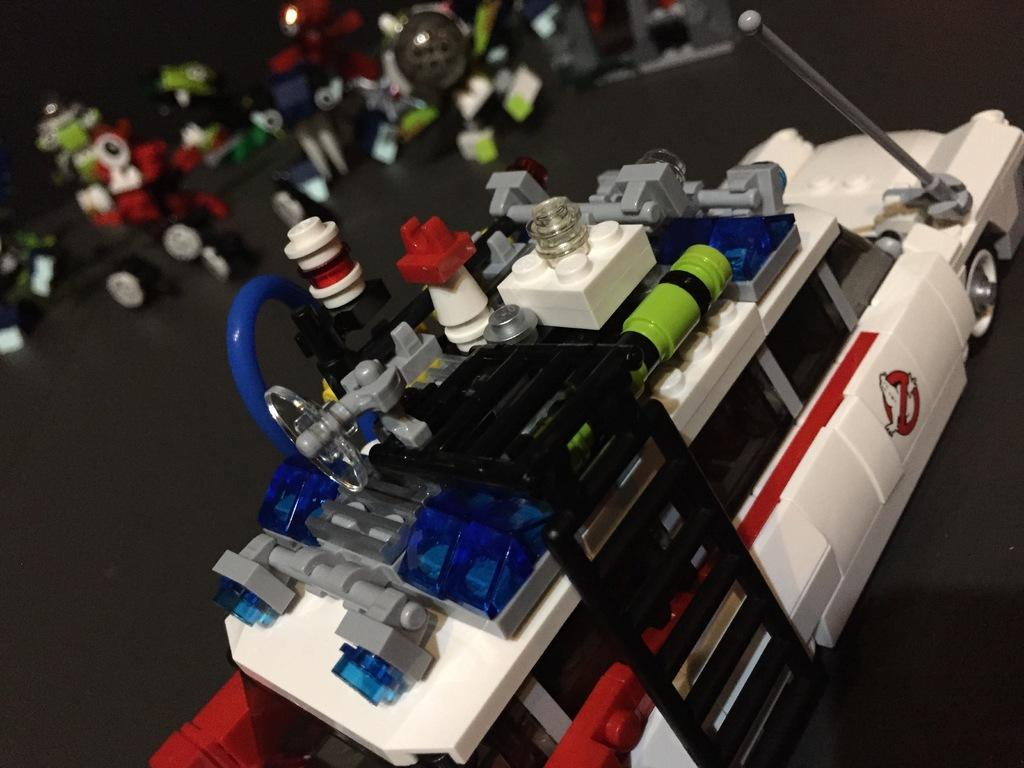What is the main subject of the image? The main subject of the image is toys. Can you describe the toy car in the image? There is a toy car in white color in the front of the image. Are there any toys visible in the background of the image? Yes, there are toys in the background of the image. What type of drink is the mother holding in the image? There is no mother or drink present in the image; it features toys and a toy car. 